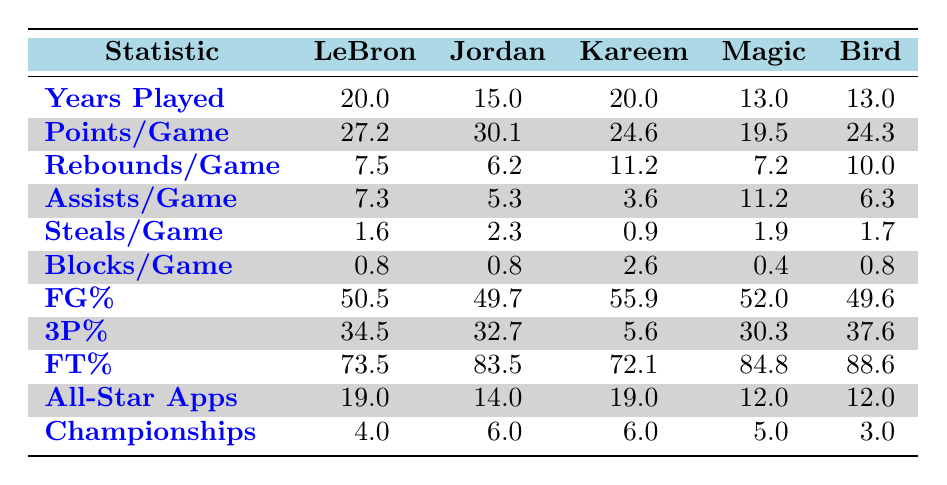What's the highest points per game among the players? The table shows that Michael Jordan has the highest points per game at 30.1.
Answer: 30.1 What is the average number of rebounds per game for all players? To find the average rebounds per game, we sum the rebounds for all players: 7.5 + 6.2 + 11.2 + 7.2 + 10.0 = 42.1. We then divide by the number of players, which is 5: 42.1 / 5 = 8.42.
Answer: 8.4 Did LeBron James have more assists per game than Kareem Abdul-Jabbar? LeBron James has 7.3 assists per game, while Kareem Abdul-Jabbar has 3.6. Since 7.3 is greater than 3.6, the statement is true.
Answer: Yes Who had the lowest free throw percentage among the players? In the table, the free throw percentages are 73.5 for LeBron, 83.5 for Jordan, 72.1 for Kareem, 84.8 for Magic, and 88.6 for Bird. The lowest is 72.1 for Kareem Abdul-Jabbar.
Answer: Kareem Abdul-Jabbar What is the difference in championships won between Michael Jordan and Larry Bird? Michael Jordan won 6 championships, while Larry Bird won 3. To find the difference, we subtract Bird's total from Jordan's: 6 - 3 = 3.
Answer: 3 